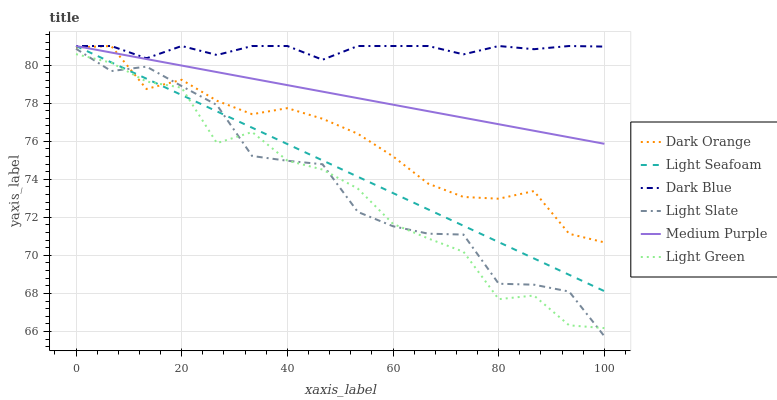Does Light Green have the minimum area under the curve?
Answer yes or no. Yes. Does Dark Blue have the maximum area under the curve?
Answer yes or no. Yes. Does Light Slate have the minimum area under the curve?
Answer yes or no. No. Does Light Slate have the maximum area under the curve?
Answer yes or no. No. Is Medium Purple the smoothest?
Answer yes or no. Yes. Is Light Green the roughest?
Answer yes or no. Yes. Is Light Slate the smoothest?
Answer yes or no. No. Is Light Slate the roughest?
Answer yes or no. No. Does Light Slate have the lowest value?
Answer yes or no. Yes. Does Medium Purple have the lowest value?
Answer yes or no. No. Does Light Seafoam have the highest value?
Answer yes or no. Yes. Does Light Slate have the highest value?
Answer yes or no. No. Is Light Slate less than Medium Purple?
Answer yes or no. Yes. Is Dark Blue greater than Light Slate?
Answer yes or no. Yes. Does Dark Orange intersect Light Slate?
Answer yes or no. Yes. Is Dark Orange less than Light Slate?
Answer yes or no. No. Is Dark Orange greater than Light Slate?
Answer yes or no. No. Does Light Slate intersect Medium Purple?
Answer yes or no. No. 